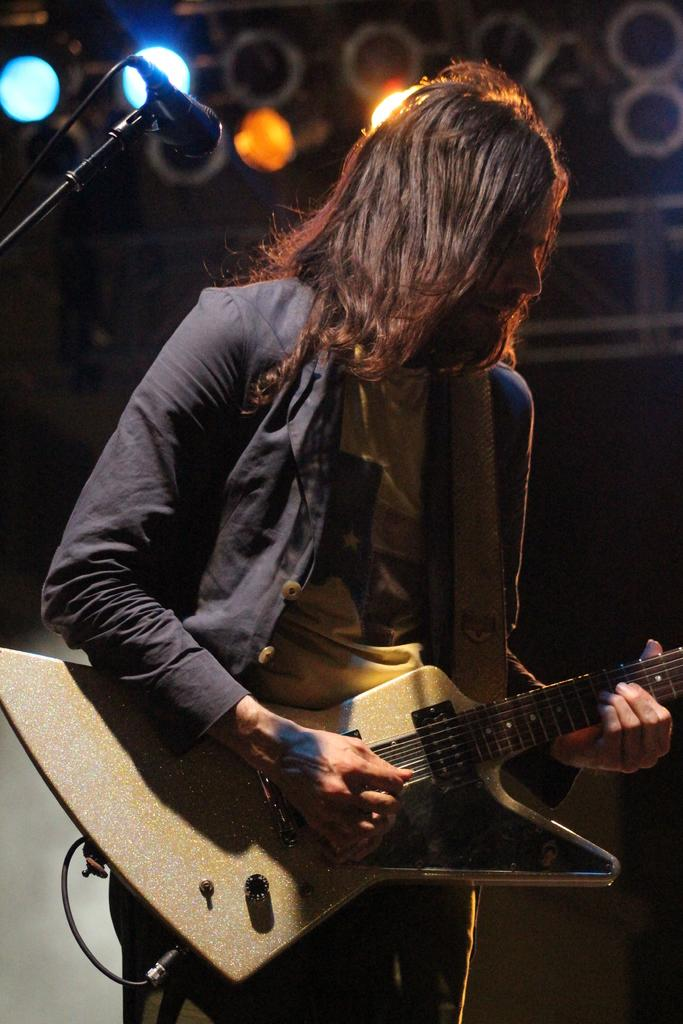What is the main subject of the image? There is a person standing in the image. What is the person wearing? The person is wearing clothes. What is the person holding in their hands? The person is holding a guitar in their hands. What other objects can be seen in the image? There is a microphone, a cable wire, and lights in the image. How would you describe the background of the image? The background of the image is dark. What type of wax can be seen melting near the person in the image? There is no wax present in the image. Can you see any docks or boats in the image? There is no dock or boat present in the image. 